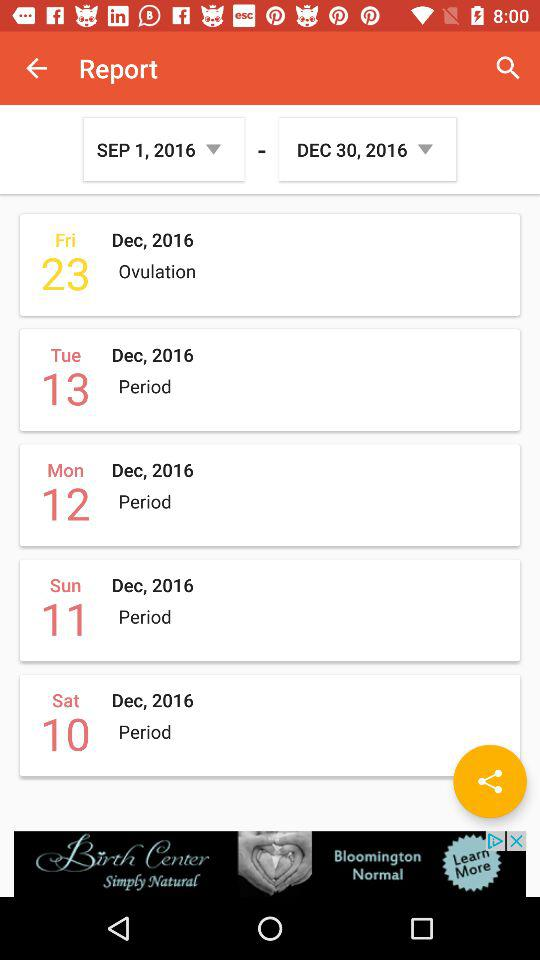What is the date range selected to view the report? The date range selected to view the report is from September 1, 2016 to December 30, 2016. 